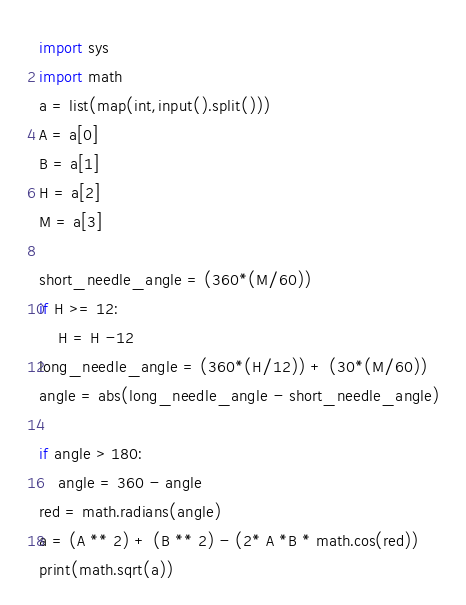<code> <loc_0><loc_0><loc_500><loc_500><_Python_>import sys 
import math
a = list(map(int,input().split()))
A = a[0]
B = a[1]
H = a[2]
M = a[3]

short_needle_angle = (360*(M/60))
if H >= 12:
    H = H -12
long_needle_angle = (360*(H/12)) + (30*(M/60))
angle = abs(long_needle_angle - short_needle_angle)

if angle > 180:
    angle = 360 - angle
red = math.radians(angle)
a = (A ** 2) + (B ** 2) - (2* A *B * math.cos(red))
print(math.sqrt(a))</code> 